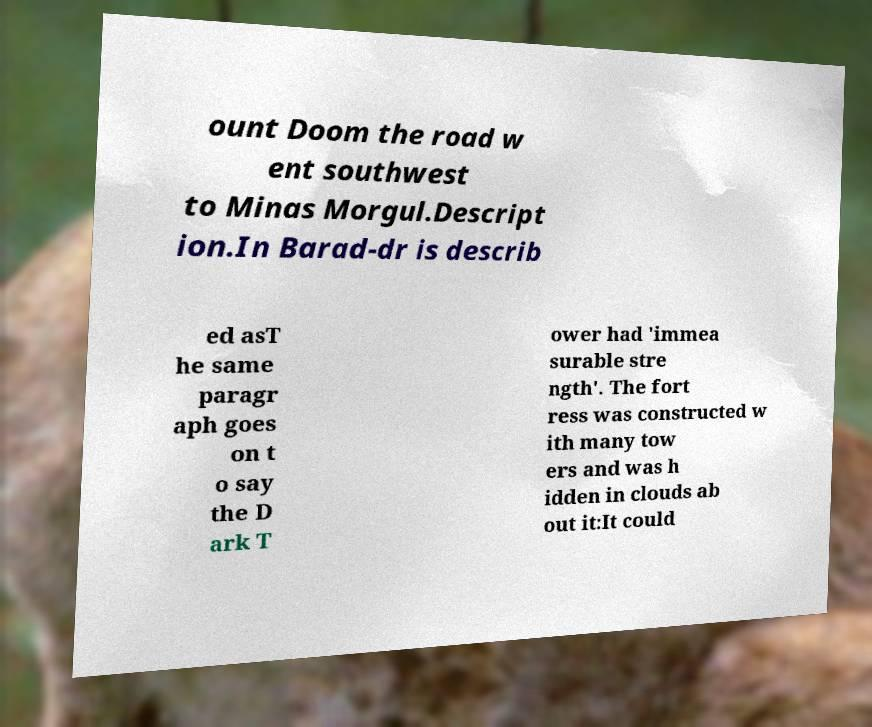For documentation purposes, I need the text within this image transcribed. Could you provide that? ount Doom the road w ent southwest to Minas Morgul.Descript ion.In Barad-dr is describ ed asT he same paragr aph goes on t o say the D ark T ower had 'immea surable stre ngth'. The fort ress was constructed w ith many tow ers and was h idden in clouds ab out it:It could 